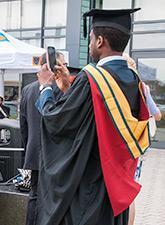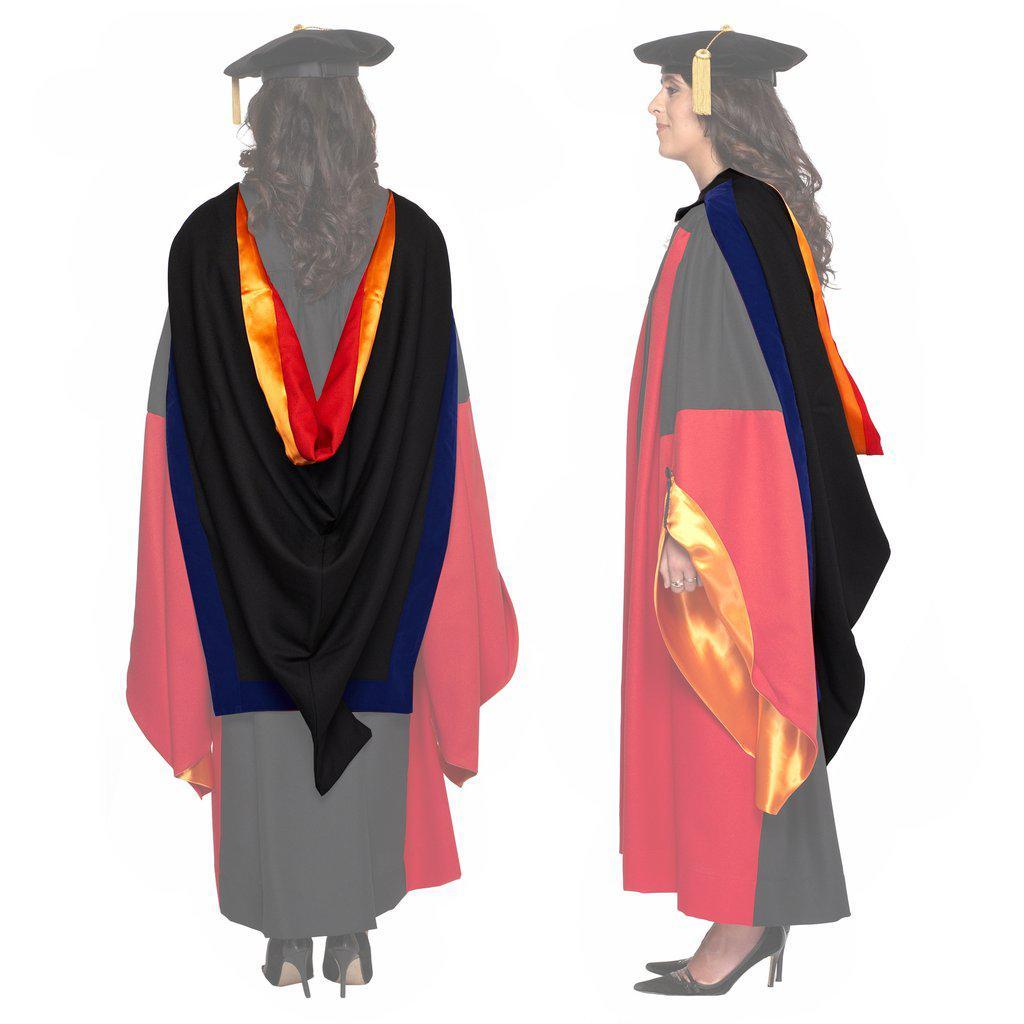The first image is the image on the left, the second image is the image on the right. Analyze the images presented: Is the assertion "A man is wearing a graduation outfit in one of the images." valid? Answer yes or no. Yes. 